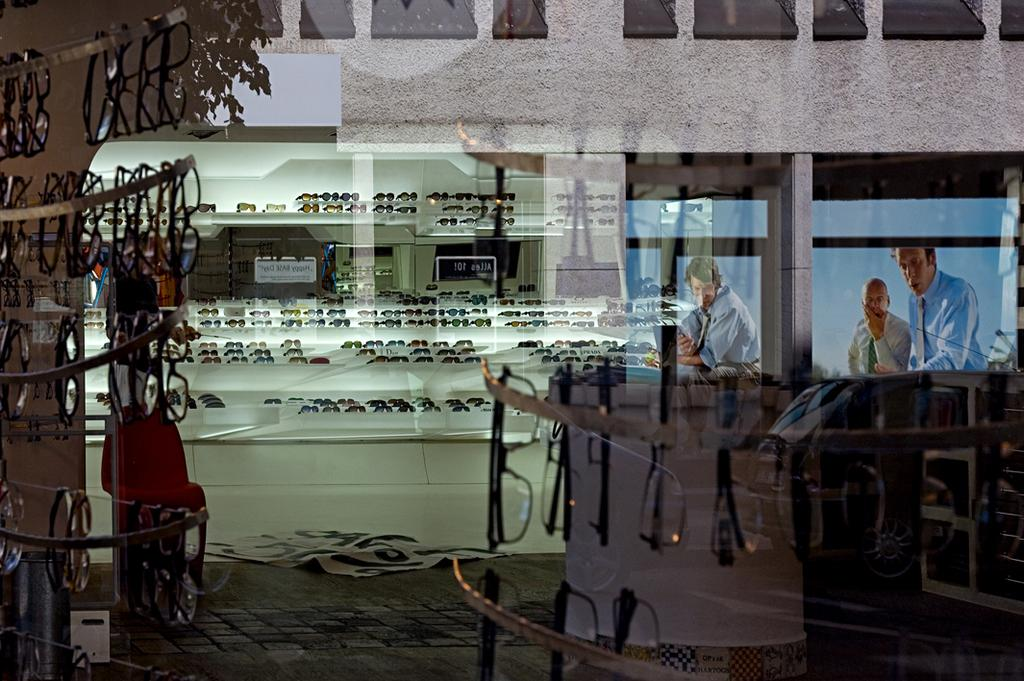What type of protective eyewear is visible in the image? There are goggles in the image. What can be used for storing or organizing items in the image? There are racks in the image. What type of decorative items are present in the image? There are posters in the image. What type of surface is visible in the image? The image shows a floor. What is visible in the background of the image? There is a wall and boards in the background of the image. What type of trousers are hanging on the wall in the image? There are no trousers visible in the image; only goggles, racks, posters, a floor, a wall, and boards are present. What color is the silver item in the image? There is no silver item present in the image. 